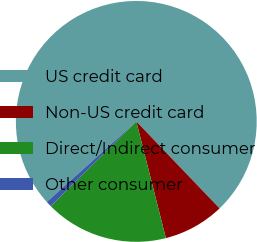Convert chart to OTSL. <chart><loc_0><loc_0><loc_500><loc_500><pie_chart><fcel>US credit card<fcel>Non-US credit card<fcel>Direct/Indirect consumer<fcel>Other consumer<nl><fcel>74.51%<fcel>8.2%<fcel>16.51%<fcel>0.78%<nl></chart> 